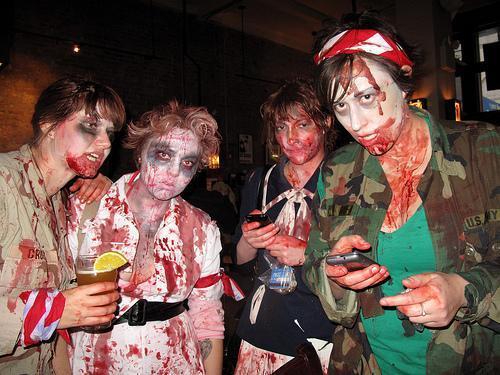How many people are in the photo?
Give a very brief answer. 4. How many cell phones are in the photo?
Give a very brief answer. 2. 